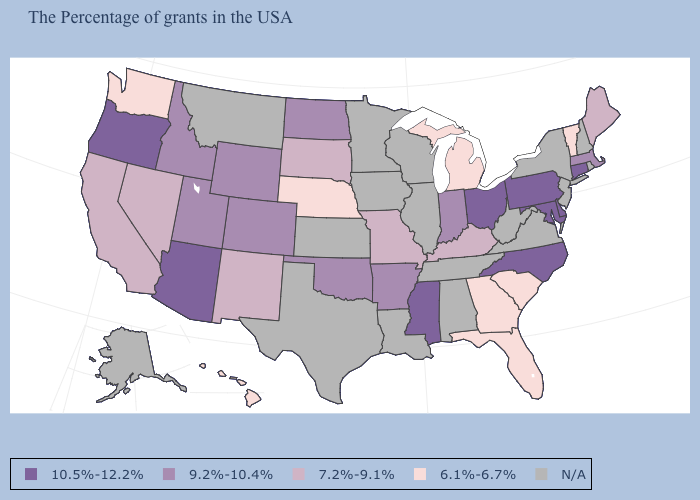Name the states that have a value in the range N/A?
Concise answer only. Rhode Island, New Hampshire, New York, New Jersey, Virginia, West Virginia, Alabama, Tennessee, Wisconsin, Illinois, Louisiana, Minnesota, Iowa, Kansas, Texas, Montana, Alaska. Which states have the highest value in the USA?
Be succinct. Connecticut, Delaware, Maryland, Pennsylvania, North Carolina, Ohio, Mississippi, Arizona, Oregon. Does Michigan have the lowest value in the MidWest?
Short answer required. Yes. How many symbols are there in the legend?
Answer briefly. 5. Among the states that border Pennsylvania , which have the lowest value?
Concise answer only. Delaware, Maryland, Ohio. Name the states that have a value in the range 7.2%-9.1%?
Give a very brief answer. Maine, Kentucky, Missouri, South Dakota, New Mexico, Nevada, California. What is the value of New Jersey?
Keep it brief. N/A. Does Hawaii have the lowest value in the West?
Answer briefly. Yes. Does Florida have the lowest value in the USA?
Give a very brief answer. Yes. What is the highest value in the MidWest ?
Give a very brief answer. 10.5%-12.2%. Does Ohio have the highest value in the USA?
Concise answer only. Yes. Name the states that have a value in the range 9.2%-10.4%?
Short answer required. Massachusetts, Indiana, Arkansas, Oklahoma, North Dakota, Wyoming, Colorado, Utah, Idaho. 